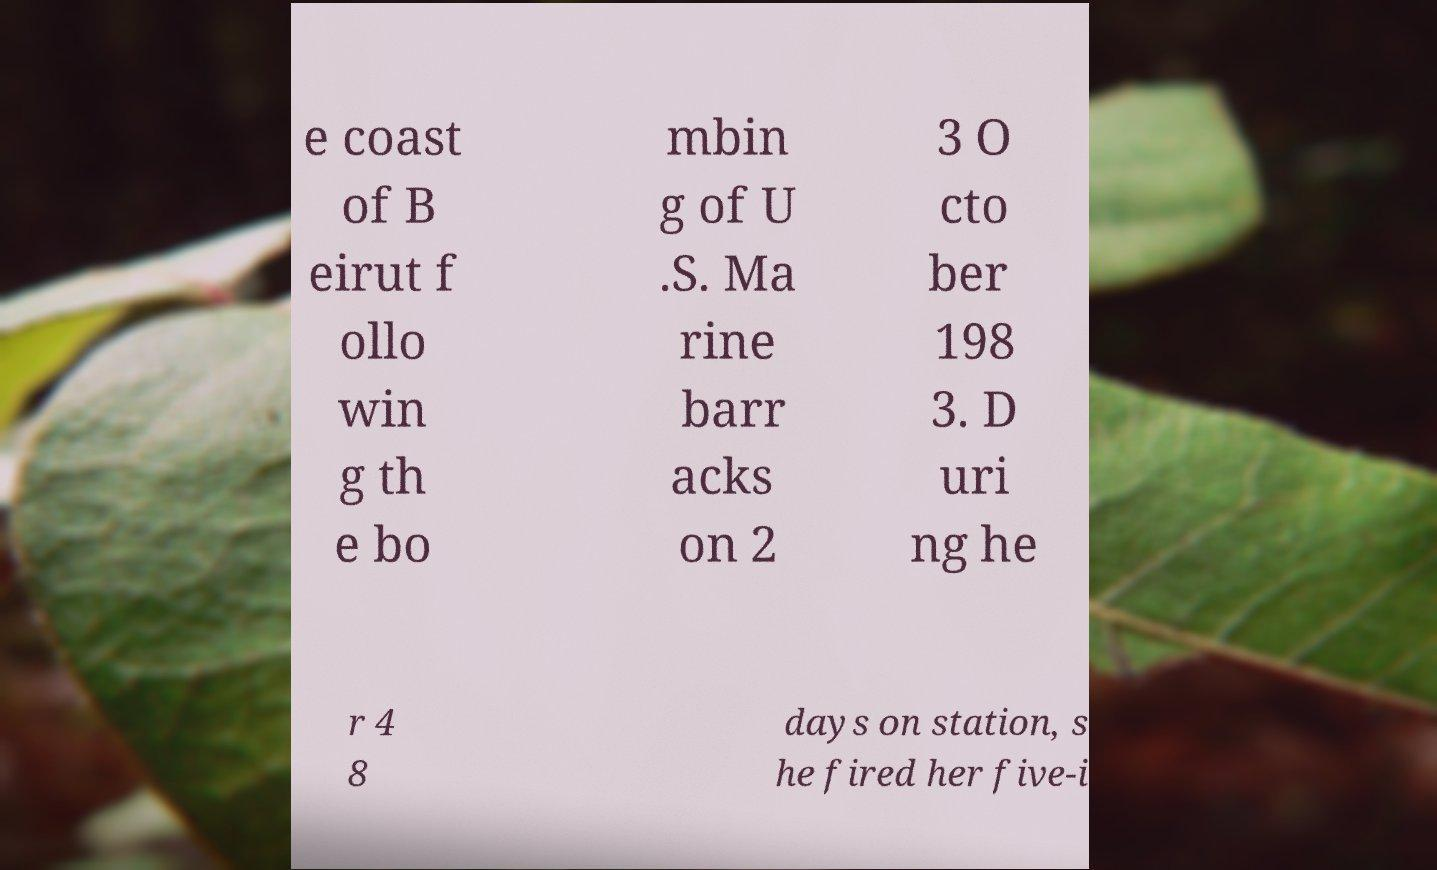Can you accurately transcribe the text from the provided image for me? e coast of B eirut f ollo win g th e bo mbin g of U .S. Ma rine barr acks on 2 3 O cto ber 198 3. D uri ng he r 4 8 days on station, s he fired her five-i 